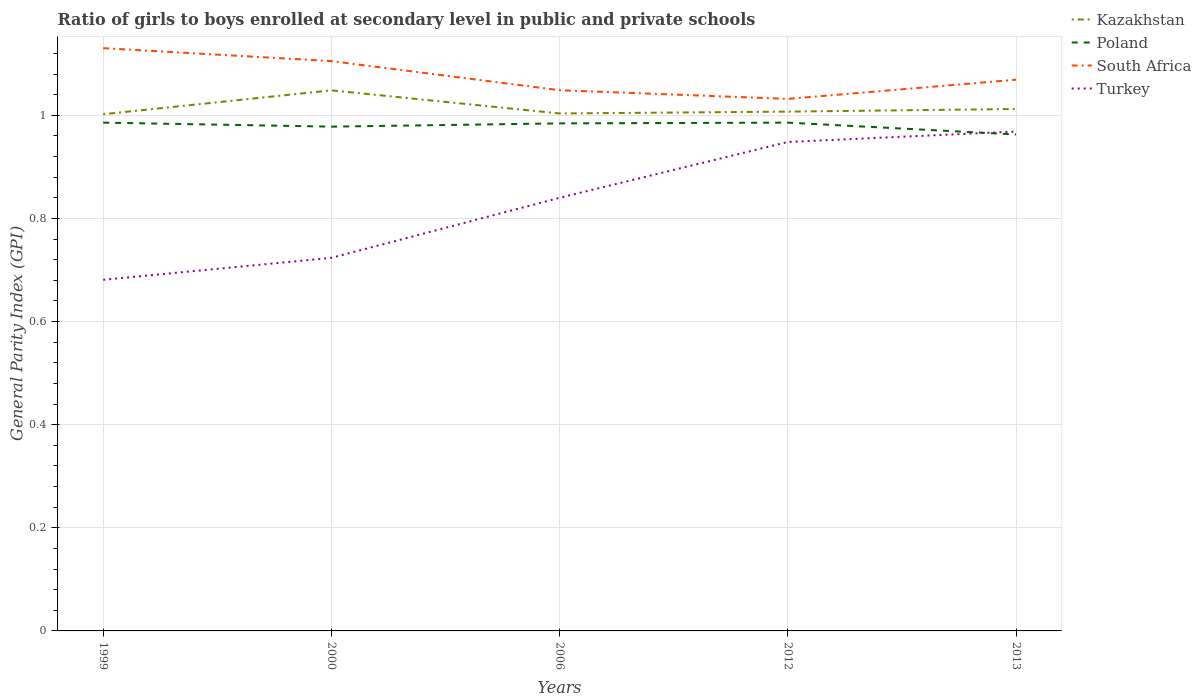How many different coloured lines are there?
Your answer should be very brief. 4. Is the number of lines equal to the number of legend labels?
Your answer should be very brief. Yes. Across all years, what is the maximum general parity index in Turkey?
Make the answer very short. 0.68. What is the total general parity index in Kazakhstan in the graph?
Give a very brief answer. 0.04. What is the difference between the highest and the second highest general parity index in Turkey?
Your answer should be very brief. 0.29. What is the difference between the highest and the lowest general parity index in Poland?
Make the answer very short. 3. Is the general parity index in South Africa strictly greater than the general parity index in Poland over the years?
Make the answer very short. No. How many lines are there?
Your response must be concise. 4. How many years are there in the graph?
Give a very brief answer. 5. What is the difference between two consecutive major ticks on the Y-axis?
Offer a very short reply. 0.2. Are the values on the major ticks of Y-axis written in scientific E-notation?
Provide a short and direct response. No. Does the graph contain any zero values?
Offer a terse response. No. What is the title of the graph?
Make the answer very short. Ratio of girls to boys enrolled at secondary level in public and private schools. What is the label or title of the Y-axis?
Your answer should be very brief. General Parity Index (GPI). What is the General Parity Index (GPI) of Kazakhstan in 1999?
Offer a terse response. 1. What is the General Parity Index (GPI) of Poland in 1999?
Keep it short and to the point. 0.99. What is the General Parity Index (GPI) of South Africa in 1999?
Ensure brevity in your answer.  1.13. What is the General Parity Index (GPI) of Turkey in 1999?
Ensure brevity in your answer.  0.68. What is the General Parity Index (GPI) in Kazakhstan in 2000?
Provide a succinct answer. 1.05. What is the General Parity Index (GPI) of Poland in 2000?
Your answer should be very brief. 0.98. What is the General Parity Index (GPI) in South Africa in 2000?
Your response must be concise. 1.11. What is the General Parity Index (GPI) in Turkey in 2000?
Ensure brevity in your answer.  0.72. What is the General Parity Index (GPI) in Kazakhstan in 2006?
Keep it short and to the point. 1. What is the General Parity Index (GPI) of Poland in 2006?
Keep it short and to the point. 0.98. What is the General Parity Index (GPI) of South Africa in 2006?
Give a very brief answer. 1.05. What is the General Parity Index (GPI) in Turkey in 2006?
Make the answer very short. 0.84. What is the General Parity Index (GPI) in Kazakhstan in 2012?
Give a very brief answer. 1.01. What is the General Parity Index (GPI) of Poland in 2012?
Offer a terse response. 0.99. What is the General Parity Index (GPI) of South Africa in 2012?
Your response must be concise. 1.03. What is the General Parity Index (GPI) of Turkey in 2012?
Ensure brevity in your answer.  0.95. What is the General Parity Index (GPI) of Kazakhstan in 2013?
Your response must be concise. 1.01. What is the General Parity Index (GPI) of Poland in 2013?
Your answer should be compact. 0.96. What is the General Parity Index (GPI) in South Africa in 2013?
Give a very brief answer. 1.07. What is the General Parity Index (GPI) of Turkey in 2013?
Give a very brief answer. 0.97. Across all years, what is the maximum General Parity Index (GPI) in Kazakhstan?
Ensure brevity in your answer.  1.05. Across all years, what is the maximum General Parity Index (GPI) of Poland?
Provide a succinct answer. 0.99. Across all years, what is the maximum General Parity Index (GPI) of South Africa?
Make the answer very short. 1.13. Across all years, what is the maximum General Parity Index (GPI) in Turkey?
Ensure brevity in your answer.  0.97. Across all years, what is the minimum General Parity Index (GPI) in Kazakhstan?
Offer a terse response. 1. Across all years, what is the minimum General Parity Index (GPI) in Poland?
Your answer should be very brief. 0.96. Across all years, what is the minimum General Parity Index (GPI) of South Africa?
Offer a terse response. 1.03. Across all years, what is the minimum General Parity Index (GPI) in Turkey?
Your answer should be compact. 0.68. What is the total General Parity Index (GPI) of Kazakhstan in the graph?
Your response must be concise. 5.07. What is the total General Parity Index (GPI) of Poland in the graph?
Give a very brief answer. 4.9. What is the total General Parity Index (GPI) in South Africa in the graph?
Keep it short and to the point. 5.38. What is the total General Parity Index (GPI) of Turkey in the graph?
Your answer should be compact. 4.16. What is the difference between the General Parity Index (GPI) of Kazakhstan in 1999 and that in 2000?
Your answer should be very brief. -0.05. What is the difference between the General Parity Index (GPI) of Poland in 1999 and that in 2000?
Your answer should be very brief. 0.01. What is the difference between the General Parity Index (GPI) in South Africa in 1999 and that in 2000?
Your answer should be compact. 0.03. What is the difference between the General Parity Index (GPI) in Turkey in 1999 and that in 2000?
Offer a terse response. -0.04. What is the difference between the General Parity Index (GPI) in Kazakhstan in 1999 and that in 2006?
Provide a short and direct response. -0. What is the difference between the General Parity Index (GPI) of Poland in 1999 and that in 2006?
Provide a succinct answer. 0. What is the difference between the General Parity Index (GPI) of South Africa in 1999 and that in 2006?
Offer a very short reply. 0.08. What is the difference between the General Parity Index (GPI) of Turkey in 1999 and that in 2006?
Provide a short and direct response. -0.16. What is the difference between the General Parity Index (GPI) of Kazakhstan in 1999 and that in 2012?
Offer a very short reply. -0.01. What is the difference between the General Parity Index (GPI) in Poland in 1999 and that in 2012?
Provide a short and direct response. -0. What is the difference between the General Parity Index (GPI) of South Africa in 1999 and that in 2012?
Offer a very short reply. 0.1. What is the difference between the General Parity Index (GPI) in Turkey in 1999 and that in 2012?
Give a very brief answer. -0.27. What is the difference between the General Parity Index (GPI) of Kazakhstan in 1999 and that in 2013?
Ensure brevity in your answer.  -0.01. What is the difference between the General Parity Index (GPI) in Poland in 1999 and that in 2013?
Give a very brief answer. 0.02. What is the difference between the General Parity Index (GPI) in South Africa in 1999 and that in 2013?
Provide a short and direct response. 0.06. What is the difference between the General Parity Index (GPI) in Turkey in 1999 and that in 2013?
Ensure brevity in your answer.  -0.29. What is the difference between the General Parity Index (GPI) of Kazakhstan in 2000 and that in 2006?
Your response must be concise. 0.04. What is the difference between the General Parity Index (GPI) of Poland in 2000 and that in 2006?
Your answer should be compact. -0.01. What is the difference between the General Parity Index (GPI) of South Africa in 2000 and that in 2006?
Ensure brevity in your answer.  0.06. What is the difference between the General Parity Index (GPI) in Turkey in 2000 and that in 2006?
Your answer should be very brief. -0.12. What is the difference between the General Parity Index (GPI) of Kazakhstan in 2000 and that in 2012?
Your response must be concise. 0.04. What is the difference between the General Parity Index (GPI) of Poland in 2000 and that in 2012?
Provide a succinct answer. -0.01. What is the difference between the General Parity Index (GPI) in South Africa in 2000 and that in 2012?
Make the answer very short. 0.07. What is the difference between the General Parity Index (GPI) in Turkey in 2000 and that in 2012?
Provide a short and direct response. -0.22. What is the difference between the General Parity Index (GPI) in Kazakhstan in 2000 and that in 2013?
Provide a succinct answer. 0.04. What is the difference between the General Parity Index (GPI) in Poland in 2000 and that in 2013?
Ensure brevity in your answer.  0.02. What is the difference between the General Parity Index (GPI) of South Africa in 2000 and that in 2013?
Provide a short and direct response. 0.04. What is the difference between the General Parity Index (GPI) of Turkey in 2000 and that in 2013?
Offer a terse response. -0.24. What is the difference between the General Parity Index (GPI) of Kazakhstan in 2006 and that in 2012?
Your answer should be very brief. -0. What is the difference between the General Parity Index (GPI) in Poland in 2006 and that in 2012?
Ensure brevity in your answer.  -0. What is the difference between the General Parity Index (GPI) of South Africa in 2006 and that in 2012?
Your response must be concise. 0.02. What is the difference between the General Parity Index (GPI) of Turkey in 2006 and that in 2012?
Provide a succinct answer. -0.11. What is the difference between the General Parity Index (GPI) of Kazakhstan in 2006 and that in 2013?
Ensure brevity in your answer.  -0.01. What is the difference between the General Parity Index (GPI) in Poland in 2006 and that in 2013?
Keep it short and to the point. 0.02. What is the difference between the General Parity Index (GPI) in South Africa in 2006 and that in 2013?
Ensure brevity in your answer.  -0.02. What is the difference between the General Parity Index (GPI) in Turkey in 2006 and that in 2013?
Provide a short and direct response. -0.13. What is the difference between the General Parity Index (GPI) of Kazakhstan in 2012 and that in 2013?
Provide a short and direct response. -0.01. What is the difference between the General Parity Index (GPI) of Poland in 2012 and that in 2013?
Offer a terse response. 0.02. What is the difference between the General Parity Index (GPI) of South Africa in 2012 and that in 2013?
Your answer should be very brief. -0.04. What is the difference between the General Parity Index (GPI) in Turkey in 2012 and that in 2013?
Give a very brief answer. -0.02. What is the difference between the General Parity Index (GPI) of Kazakhstan in 1999 and the General Parity Index (GPI) of Poland in 2000?
Make the answer very short. 0.02. What is the difference between the General Parity Index (GPI) in Kazakhstan in 1999 and the General Parity Index (GPI) in South Africa in 2000?
Make the answer very short. -0.1. What is the difference between the General Parity Index (GPI) in Kazakhstan in 1999 and the General Parity Index (GPI) in Turkey in 2000?
Offer a terse response. 0.28. What is the difference between the General Parity Index (GPI) of Poland in 1999 and the General Parity Index (GPI) of South Africa in 2000?
Give a very brief answer. -0.12. What is the difference between the General Parity Index (GPI) of Poland in 1999 and the General Parity Index (GPI) of Turkey in 2000?
Keep it short and to the point. 0.26. What is the difference between the General Parity Index (GPI) in South Africa in 1999 and the General Parity Index (GPI) in Turkey in 2000?
Keep it short and to the point. 0.41. What is the difference between the General Parity Index (GPI) of Kazakhstan in 1999 and the General Parity Index (GPI) of Poland in 2006?
Your answer should be very brief. 0.02. What is the difference between the General Parity Index (GPI) of Kazakhstan in 1999 and the General Parity Index (GPI) of South Africa in 2006?
Offer a very short reply. -0.05. What is the difference between the General Parity Index (GPI) of Kazakhstan in 1999 and the General Parity Index (GPI) of Turkey in 2006?
Make the answer very short. 0.16. What is the difference between the General Parity Index (GPI) of Poland in 1999 and the General Parity Index (GPI) of South Africa in 2006?
Your answer should be very brief. -0.06. What is the difference between the General Parity Index (GPI) of Poland in 1999 and the General Parity Index (GPI) of Turkey in 2006?
Give a very brief answer. 0.15. What is the difference between the General Parity Index (GPI) in South Africa in 1999 and the General Parity Index (GPI) in Turkey in 2006?
Ensure brevity in your answer.  0.29. What is the difference between the General Parity Index (GPI) of Kazakhstan in 1999 and the General Parity Index (GPI) of Poland in 2012?
Ensure brevity in your answer.  0.02. What is the difference between the General Parity Index (GPI) in Kazakhstan in 1999 and the General Parity Index (GPI) in South Africa in 2012?
Ensure brevity in your answer.  -0.03. What is the difference between the General Parity Index (GPI) of Kazakhstan in 1999 and the General Parity Index (GPI) of Turkey in 2012?
Provide a short and direct response. 0.05. What is the difference between the General Parity Index (GPI) of Poland in 1999 and the General Parity Index (GPI) of South Africa in 2012?
Give a very brief answer. -0.05. What is the difference between the General Parity Index (GPI) of Poland in 1999 and the General Parity Index (GPI) of Turkey in 2012?
Your response must be concise. 0.04. What is the difference between the General Parity Index (GPI) in South Africa in 1999 and the General Parity Index (GPI) in Turkey in 2012?
Your answer should be very brief. 0.18. What is the difference between the General Parity Index (GPI) of Kazakhstan in 1999 and the General Parity Index (GPI) of Poland in 2013?
Keep it short and to the point. 0.04. What is the difference between the General Parity Index (GPI) of Kazakhstan in 1999 and the General Parity Index (GPI) of South Africa in 2013?
Make the answer very short. -0.07. What is the difference between the General Parity Index (GPI) in Kazakhstan in 1999 and the General Parity Index (GPI) in Turkey in 2013?
Offer a terse response. 0.03. What is the difference between the General Parity Index (GPI) of Poland in 1999 and the General Parity Index (GPI) of South Africa in 2013?
Offer a terse response. -0.08. What is the difference between the General Parity Index (GPI) of Poland in 1999 and the General Parity Index (GPI) of Turkey in 2013?
Offer a terse response. 0.02. What is the difference between the General Parity Index (GPI) of South Africa in 1999 and the General Parity Index (GPI) of Turkey in 2013?
Your response must be concise. 0.16. What is the difference between the General Parity Index (GPI) of Kazakhstan in 2000 and the General Parity Index (GPI) of Poland in 2006?
Offer a terse response. 0.06. What is the difference between the General Parity Index (GPI) in Kazakhstan in 2000 and the General Parity Index (GPI) in South Africa in 2006?
Provide a short and direct response. -0. What is the difference between the General Parity Index (GPI) of Kazakhstan in 2000 and the General Parity Index (GPI) of Turkey in 2006?
Your answer should be very brief. 0.21. What is the difference between the General Parity Index (GPI) in Poland in 2000 and the General Parity Index (GPI) in South Africa in 2006?
Offer a terse response. -0.07. What is the difference between the General Parity Index (GPI) in Poland in 2000 and the General Parity Index (GPI) in Turkey in 2006?
Offer a terse response. 0.14. What is the difference between the General Parity Index (GPI) in South Africa in 2000 and the General Parity Index (GPI) in Turkey in 2006?
Your answer should be compact. 0.27. What is the difference between the General Parity Index (GPI) in Kazakhstan in 2000 and the General Parity Index (GPI) in Poland in 2012?
Make the answer very short. 0.06. What is the difference between the General Parity Index (GPI) in Kazakhstan in 2000 and the General Parity Index (GPI) in South Africa in 2012?
Your answer should be very brief. 0.02. What is the difference between the General Parity Index (GPI) of Kazakhstan in 2000 and the General Parity Index (GPI) of Turkey in 2012?
Make the answer very short. 0.1. What is the difference between the General Parity Index (GPI) of Poland in 2000 and the General Parity Index (GPI) of South Africa in 2012?
Provide a succinct answer. -0.05. What is the difference between the General Parity Index (GPI) of Poland in 2000 and the General Parity Index (GPI) of Turkey in 2012?
Provide a succinct answer. 0.03. What is the difference between the General Parity Index (GPI) of South Africa in 2000 and the General Parity Index (GPI) of Turkey in 2012?
Your response must be concise. 0.16. What is the difference between the General Parity Index (GPI) of Kazakhstan in 2000 and the General Parity Index (GPI) of Poland in 2013?
Offer a terse response. 0.09. What is the difference between the General Parity Index (GPI) of Kazakhstan in 2000 and the General Parity Index (GPI) of South Africa in 2013?
Ensure brevity in your answer.  -0.02. What is the difference between the General Parity Index (GPI) in Kazakhstan in 2000 and the General Parity Index (GPI) in Turkey in 2013?
Ensure brevity in your answer.  0.08. What is the difference between the General Parity Index (GPI) of Poland in 2000 and the General Parity Index (GPI) of South Africa in 2013?
Keep it short and to the point. -0.09. What is the difference between the General Parity Index (GPI) in Poland in 2000 and the General Parity Index (GPI) in Turkey in 2013?
Your answer should be very brief. 0.01. What is the difference between the General Parity Index (GPI) in South Africa in 2000 and the General Parity Index (GPI) in Turkey in 2013?
Make the answer very short. 0.14. What is the difference between the General Parity Index (GPI) in Kazakhstan in 2006 and the General Parity Index (GPI) in Poland in 2012?
Make the answer very short. 0.02. What is the difference between the General Parity Index (GPI) of Kazakhstan in 2006 and the General Parity Index (GPI) of South Africa in 2012?
Ensure brevity in your answer.  -0.03. What is the difference between the General Parity Index (GPI) of Kazakhstan in 2006 and the General Parity Index (GPI) of Turkey in 2012?
Offer a very short reply. 0.06. What is the difference between the General Parity Index (GPI) in Poland in 2006 and the General Parity Index (GPI) in South Africa in 2012?
Offer a very short reply. -0.05. What is the difference between the General Parity Index (GPI) of Poland in 2006 and the General Parity Index (GPI) of Turkey in 2012?
Offer a very short reply. 0.04. What is the difference between the General Parity Index (GPI) of South Africa in 2006 and the General Parity Index (GPI) of Turkey in 2012?
Provide a succinct answer. 0.1. What is the difference between the General Parity Index (GPI) in Kazakhstan in 2006 and the General Parity Index (GPI) in Poland in 2013?
Your answer should be very brief. 0.04. What is the difference between the General Parity Index (GPI) in Kazakhstan in 2006 and the General Parity Index (GPI) in South Africa in 2013?
Provide a short and direct response. -0.07. What is the difference between the General Parity Index (GPI) in Kazakhstan in 2006 and the General Parity Index (GPI) in Turkey in 2013?
Make the answer very short. 0.04. What is the difference between the General Parity Index (GPI) of Poland in 2006 and the General Parity Index (GPI) of South Africa in 2013?
Your answer should be compact. -0.08. What is the difference between the General Parity Index (GPI) of Poland in 2006 and the General Parity Index (GPI) of Turkey in 2013?
Your answer should be very brief. 0.02. What is the difference between the General Parity Index (GPI) in South Africa in 2006 and the General Parity Index (GPI) in Turkey in 2013?
Provide a short and direct response. 0.08. What is the difference between the General Parity Index (GPI) in Kazakhstan in 2012 and the General Parity Index (GPI) in Poland in 2013?
Make the answer very short. 0.04. What is the difference between the General Parity Index (GPI) of Kazakhstan in 2012 and the General Parity Index (GPI) of South Africa in 2013?
Provide a succinct answer. -0.06. What is the difference between the General Parity Index (GPI) of Kazakhstan in 2012 and the General Parity Index (GPI) of Turkey in 2013?
Keep it short and to the point. 0.04. What is the difference between the General Parity Index (GPI) in Poland in 2012 and the General Parity Index (GPI) in South Africa in 2013?
Give a very brief answer. -0.08. What is the difference between the General Parity Index (GPI) in Poland in 2012 and the General Parity Index (GPI) in Turkey in 2013?
Make the answer very short. 0.02. What is the difference between the General Parity Index (GPI) in South Africa in 2012 and the General Parity Index (GPI) in Turkey in 2013?
Offer a very short reply. 0.06. What is the average General Parity Index (GPI) of Kazakhstan per year?
Give a very brief answer. 1.01. What is the average General Parity Index (GPI) of Poland per year?
Give a very brief answer. 0.98. What is the average General Parity Index (GPI) in Turkey per year?
Your response must be concise. 0.83. In the year 1999, what is the difference between the General Parity Index (GPI) in Kazakhstan and General Parity Index (GPI) in Poland?
Keep it short and to the point. 0.02. In the year 1999, what is the difference between the General Parity Index (GPI) of Kazakhstan and General Parity Index (GPI) of South Africa?
Offer a very short reply. -0.13. In the year 1999, what is the difference between the General Parity Index (GPI) in Kazakhstan and General Parity Index (GPI) in Turkey?
Provide a short and direct response. 0.32. In the year 1999, what is the difference between the General Parity Index (GPI) of Poland and General Parity Index (GPI) of South Africa?
Keep it short and to the point. -0.14. In the year 1999, what is the difference between the General Parity Index (GPI) of Poland and General Parity Index (GPI) of Turkey?
Ensure brevity in your answer.  0.3. In the year 1999, what is the difference between the General Parity Index (GPI) in South Africa and General Parity Index (GPI) in Turkey?
Your response must be concise. 0.45. In the year 2000, what is the difference between the General Parity Index (GPI) of Kazakhstan and General Parity Index (GPI) of Poland?
Make the answer very short. 0.07. In the year 2000, what is the difference between the General Parity Index (GPI) in Kazakhstan and General Parity Index (GPI) in South Africa?
Offer a terse response. -0.06. In the year 2000, what is the difference between the General Parity Index (GPI) of Kazakhstan and General Parity Index (GPI) of Turkey?
Make the answer very short. 0.32. In the year 2000, what is the difference between the General Parity Index (GPI) of Poland and General Parity Index (GPI) of South Africa?
Provide a short and direct response. -0.13. In the year 2000, what is the difference between the General Parity Index (GPI) in Poland and General Parity Index (GPI) in Turkey?
Provide a succinct answer. 0.25. In the year 2000, what is the difference between the General Parity Index (GPI) of South Africa and General Parity Index (GPI) of Turkey?
Provide a succinct answer. 0.38. In the year 2006, what is the difference between the General Parity Index (GPI) in Kazakhstan and General Parity Index (GPI) in Poland?
Make the answer very short. 0.02. In the year 2006, what is the difference between the General Parity Index (GPI) in Kazakhstan and General Parity Index (GPI) in South Africa?
Offer a terse response. -0.05. In the year 2006, what is the difference between the General Parity Index (GPI) of Kazakhstan and General Parity Index (GPI) of Turkey?
Keep it short and to the point. 0.16. In the year 2006, what is the difference between the General Parity Index (GPI) of Poland and General Parity Index (GPI) of South Africa?
Offer a terse response. -0.06. In the year 2006, what is the difference between the General Parity Index (GPI) in Poland and General Parity Index (GPI) in Turkey?
Give a very brief answer. 0.14. In the year 2006, what is the difference between the General Parity Index (GPI) in South Africa and General Parity Index (GPI) in Turkey?
Offer a very short reply. 0.21. In the year 2012, what is the difference between the General Parity Index (GPI) of Kazakhstan and General Parity Index (GPI) of Poland?
Your response must be concise. 0.02. In the year 2012, what is the difference between the General Parity Index (GPI) of Kazakhstan and General Parity Index (GPI) of South Africa?
Provide a succinct answer. -0.02. In the year 2012, what is the difference between the General Parity Index (GPI) in Kazakhstan and General Parity Index (GPI) in Turkey?
Provide a short and direct response. 0.06. In the year 2012, what is the difference between the General Parity Index (GPI) in Poland and General Parity Index (GPI) in South Africa?
Ensure brevity in your answer.  -0.05. In the year 2012, what is the difference between the General Parity Index (GPI) in Poland and General Parity Index (GPI) in Turkey?
Give a very brief answer. 0.04. In the year 2012, what is the difference between the General Parity Index (GPI) in South Africa and General Parity Index (GPI) in Turkey?
Keep it short and to the point. 0.08. In the year 2013, what is the difference between the General Parity Index (GPI) of Kazakhstan and General Parity Index (GPI) of Poland?
Offer a very short reply. 0.05. In the year 2013, what is the difference between the General Parity Index (GPI) of Kazakhstan and General Parity Index (GPI) of South Africa?
Offer a terse response. -0.06. In the year 2013, what is the difference between the General Parity Index (GPI) of Kazakhstan and General Parity Index (GPI) of Turkey?
Offer a very short reply. 0.04. In the year 2013, what is the difference between the General Parity Index (GPI) of Poland and General Parity Index (GPI) of South Africa?
Ensure brevity in your answer.  -0.11. In the year 2013, what is the difference between the General Parity Index (GPI) in Poland and General Parity Index (GPI) in Turkey?
Provide a succinct answer. -0.01. In the year 2013, what is the difference between the General Parity Index (GPI) of South Africa and General Parity Index (GPI) of Turkey?
Offer a very short reply. 0.1. What is the ratio of the General Parity Index (GPI) of Kazakhstan in 1999 to that in 2000?
Offer a terse response. 0.96. What is the ratio of the General Parity Index (GPI) in South Africa in 1999 to that in 2000?
Provide a short and direct response. 1.02. What is the ratio of the General Parity Index (GPI) in Turkey in 1999 to that in 2000?
Give a very brief answer. 0.94. What is the ratio of the General Parity Index (GPI) in Kazakhstan in 1999 to that in 2006?
Make the answer very short. 1. What is the ratio of the General Parity Index (GPI) in Poland in 1999 to that in 2006?
Ensure brevity in your answer.  1. What is the ratio of the General Parity Index (GPI) in South Africa in 1999 to that in 2006?
Ensure brevity in your answer.  1.08. What is the ratio of the General Parity Index (GPI) of Turkey in 1999 to that in 2006?
Offer a very short reply. 0.81. What is the ratio of the General Parity Index (GPI) in Kazakhstan in 1999 to that in 2012?
Offer a very short reply. 0.99. What is the ratio of the General Parity Index (GPI) of Poland in 1999 to that in 2012?
Offer a terse response. 1. What is the ratio of the General Parity Index (GPI) in South Africa in 1999 to that in 2012?
Your answer should be very brief. 1.1. What is the ratio of the General Parity Index (GPI) of Turkey in 1999 to that in 2012?
Give a very brief answer. 0.72. What is the ratio of the General Parity Index (GPI) in Poland in 1999 to that in 2013?
Offer a terse response. 1.02. What is the ratio of the General Parity Index (GPI) of South Africa in 1999 to that in 2013?
Your response must be concise. 1.06. What is the ratio of the General Parity Index (GPI) in Turkey in 1999 to that in 2013?
Provide a short and direct response. 0.7. What is the ratio of the General Parity Index (GPI) of Kazakhstan in 2000 to that in 2006?
Your answer should be very brief. 1.04. What is the ratio of the General Parity Index (GPI) of South Africa in 2000 to that in 2006?
Make the answer very short. 1.05. What is the ratio of the General Parity Index (GPI) of Turkey in 2000 to that in 2006?
Make the answer very short. 0.86. What is the ratio of the General Parity Index (GPI) of Kazakhstan in 2000 to that in 2012?
Keep it short and to the point. 1.04. What is the ratio of the General Parity Index (GPI) in South Africa in 2000 to that in 2012?
Your answer should be compact. 1.07. What is the ratio of the General Parity Index (GPI) of Turkey in 2000 to that in 2012?
Give a very brief answer. 0.76. What is the ratio of the General Parity Index (GPI) of Kazakhstan in 2000 to that in 2013?
Offer a very short reply. 1.04. What is the ratio of the General Parity Index (GPI) of Poland in 2000 to that in 2013?
Provide a short and direct response. 1.02. What is the ratio of the General Parity Index (GPI) of South Africa in 2000 to that in 2013?
Offer a terse response. 1.03. What is the ratio of the General Parity Index (GPI) of Turkey in 2000 to that in 2013?
Your response must be concise. 0.75. What is the ratio of the General Parity Index (GPI) of South Africa in 2006 to that in 2012?
Keep it short and to the point. 1.02. What is the ratio of the General Parity Index (GPI) of Turkey in 2006 to that in 2012?
Offer a very short reply. 0.89. What is the ratio of the General Parity Index (GPI) of Kazakhstan in 2006 to that in 2013?
Your answer should be very brief. 0.99. What is the ratio of the General Parity Index (GPI) of Poland in 2006 to that in 2013?
Your answer should be very brief. 1.02. What is the ratio of the General Parity Index (GPI) of Turkey in 2006 to that in 2013?
Your answer should be very brief. 0.87. What is the ratio of the General Parity Index (GPI) in Kazakhstan in 2012 to that in 2013?
Your response must be concise. 0.99. What is the ratio of the General Parity Index (GPI) in Poland in 2012 to that in 2013?
Your response must be concise. 1.02. What is the ratio of the General Parity Index (GPI) in South Africa in 2012 to that in 2013?
Your response must be concise. 0.97. What is the ratio of the General Parity Index (GPI) in Turkey in 2012 to that in 2013?
Provide a short and direct response. 0.98. What is the difference between the highest and the second highest General Parity Index (GPI) of Kazakhstan?
Give a very brief answer. 0.04. What is the difference between the highest and the second highest General Parity Index (GPI) in South Africa?
Provide a succinct answer. 0.03. What is the difference between the highest and the second highest General Parity Index (GPI) of Turkey?
Provide a succinct answer. 0.02. What is the difference between the highest and the lowest General Parity Index (GPI) of Kazakhstan?
Make the answer very short. 0.05. What is the difference between the highest and the lowest General Parity Index (GPI) in Poland?
Make the answer very short. 0.02. What is the difference between the highest and the lowest General Parity Index (GPI) of South Africa?
Your answer should be compact. 0.1. What is the difference between the highest and the lowest General Parity Index (GPI) of Turkey?
Your response must be concise. 0.29. 